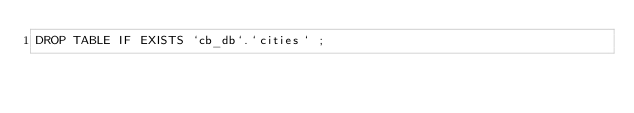Convert code to text. <code><loc_0><loc_0><loc_500><loc_500><_SQL_>DROP TABLE IF EXISTS `cb_db`.`cities` ;
</code> 